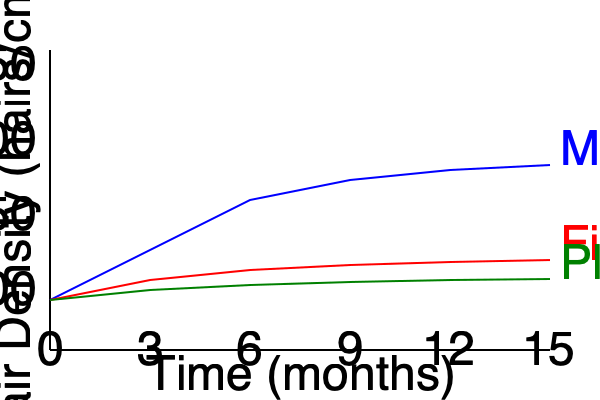Based on the graph comparing the effectiveness of different hair regrowth treatments over time, calculate the percentage increase in hair density for Minoxidil treatment after 15 months compared to the initial density. Assume the initial hair density is 100 hairs/cm². To calculate the percentage increase in hair density for Minoxidil treatment after 15 months:

1. Identify the initial hair density:
   Initial density = 100 hairs/cm²

2. Estimate the hair density after 15 months of Minoxidil treatment:
   From the graph, at 15 months (x-axis = 550), the blue line (Minoxidil) reaches approximately 235 hairs/cm²

3. Calculate the absolute increase in hair density:
   Increase = Final density - Initial density
   Increase = 235 - 100 = 135 hairs/cm²

4. Calculate the percentage increase:
   Percentage increase = (Increase / Initial density) × 100%
   Percentage increase = (135 / 100) × 100% = 135%

Therefore, the percentage increase in hair density for Minoxidil treatment after 15 months is approximately 135%.
Answer: 135% 